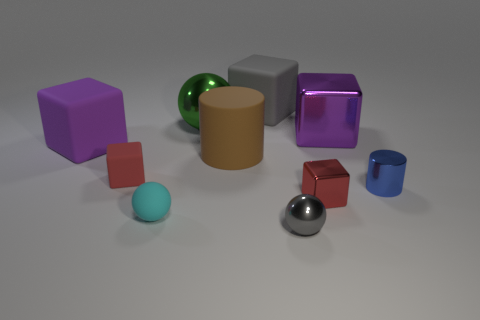Can you describe the shapes and colors of the objects in the image? Certainly! In the image, there are several objects, each with a distinct shape and color. To the left, there is a purple cube and a small red cube, and in the center, a green shiny sphere rests next to a matte brown cylinder. On the right, there's a translucent purple cube, and in front of it, a small blue cylinder. Scattered around are a small light blue sphere, a red cube, and a silver sphere. 